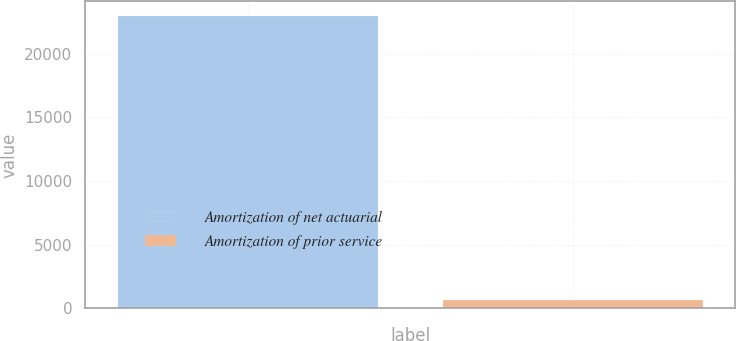Convert chart. <chart><loc_0><loc_0><loc_500><loc_500><bar_chart><fcel>Amortization of net actuarial<fcel>Amortization of prior service<nl><fcel>22952<fcel>668<nl></chart> 